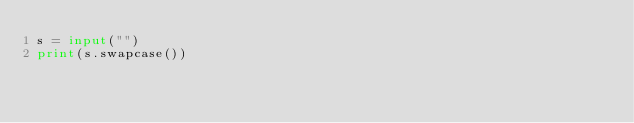Convert code to text. <code><loc_0><loc_0><loc_500><loc_500><_Python_>s = input("")
print(s.swapcase())
</code> 